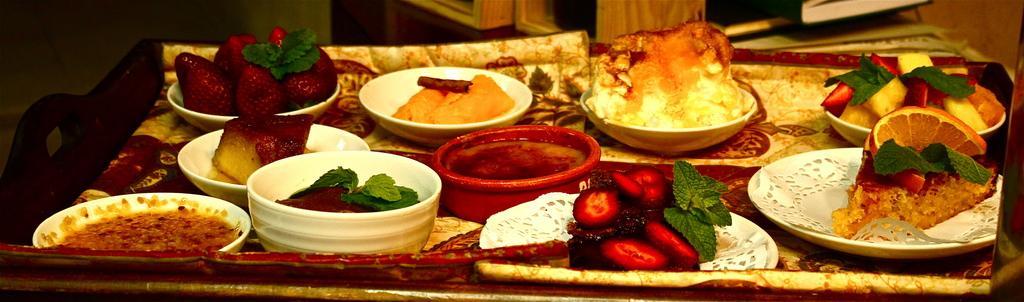How would you summarize this image in a sentence or two? The picture consists of a tray, in the tray there are bowls, plates served with different dishes. At the top there are books and cupboard. 